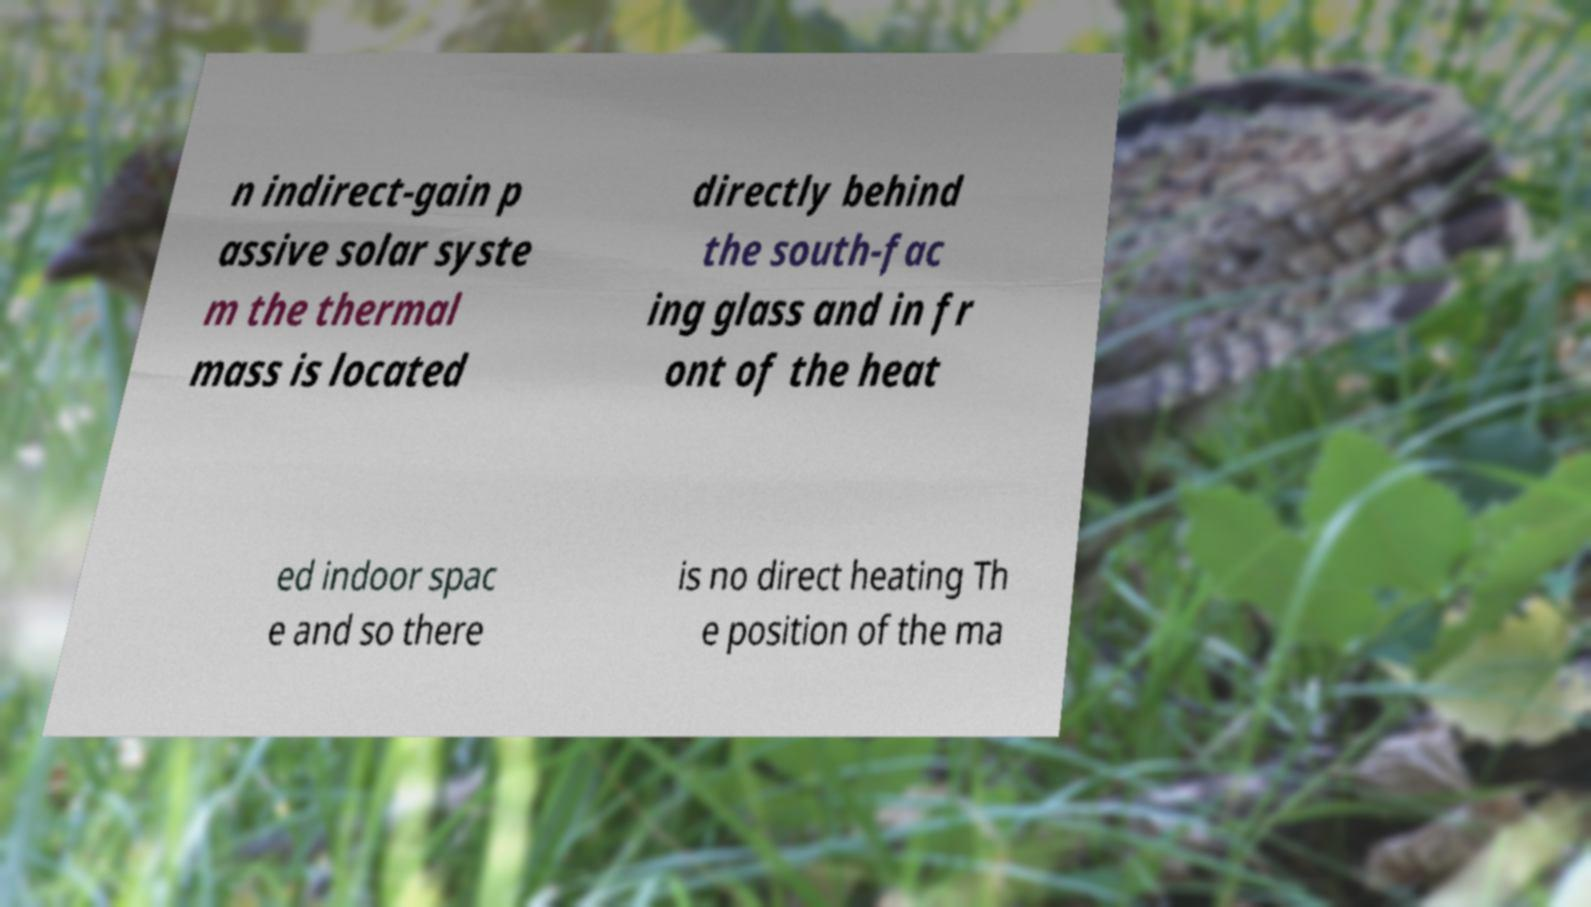Can you accurately transcribe the text from the provided image for me? n indirect-gain p assive solar syste m the thermal mass is located directly behind the south-fac ing glass and in fr ont of the heat ed indoor spac e and so there is no direct heating Th e position of the ma 